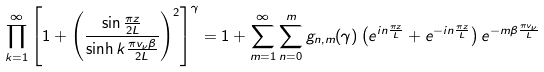Convert formula to latex. <formula><loc_0><loc_0><loc_500><loc_500>\prod _ { k = 1 } ^ { \infty } \left [ 1 + \left ( \frac { \sin \frac { \pi z } { 2 L } } { \sinh { k \frac { \pi v _ { \nu } \beta } { 2 L } } } \right ) ^ { 2 } \right ] ^ { \gamma } = 1 + \sum _ { m = 1 } ^ { \infty } \sum _ { n = 0 } ^ { m } g _ { n , m } ( \gamma ) \left ( e ^ { i n \frac { \pi z } { L } } + e ^ { - i n \frac { \pi z } { L } } \right ) e ^ { - m \beta \frac { \pi v _ { \nu } } { L } }</formula> 